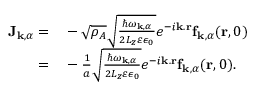<formula> <loc_0><loc_0><loc_500><loc_500>\begin{array} { r l } { J _ { k , \alpha } = } & - \sqrt { \rho _ { A } } \sqrt { \frac { \hbar { \omega } _ { k , \alpha } } { 2 L _ { z } \varepsilon \epsilon _ { 0 } } } e ^ { - i k . r } f _ { k , \alpha } ( r , 0 ) } \\ { = } & - \frac { 1 } { a } \sqrt { \frac { \hbar { \omega } _ { k , \alpha } } { 2 L _ { z } \varepsilon \epsilon _ { 0 } } } e ^ { - i k . r } f _ { k , \alpha } ( r , 0 ) . } \end{array}</formula> 